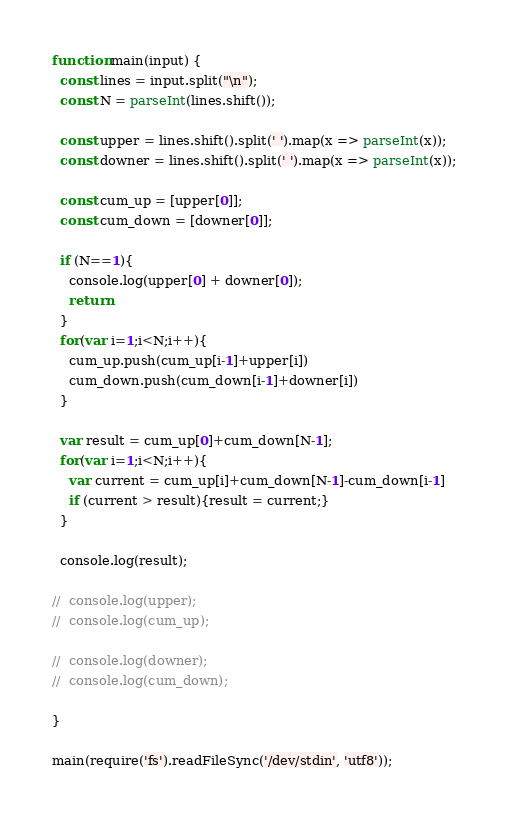Convert code to text. <code><loc_0><loc_0><loc_500><loc_500><_JavaScript_>function main(input) {
  const lines = input.split("\n");
  const N = parseInt(lines.shift());

  const upper = lines.shift().split(' ').map(x => parseInt(x));
  const downer = lines.shift().split(' ').map(x => parseInt(x));

  const cum_up = [upper[0]];
  const cum_down = [downer[0]];

  if (N==1){
    console.log(upper[0] + downer[0]);
    return
  }
  for(var i=1;i<N;i++){
    cum_up.push(cum_up[i-1]+upper[i])
    cum_down.push(cum_down[i-1]+downer[i])
  }

  var result = cum_up[0]+cum_down[N-1];
  for(var i=1;i<N;i++){
    var current = cum_up[i]+cum_down[N-1]-cum_down[i-1]
    if (current > result){result = current;}
  }

  console.log(result);

//  console.log(upper);
//  console.log(cum_up);

//  console.log(downer);
//  console.log(cum_down);

}

main(require('fs').readFileSync('/dev/stdin', 'utf8'));

</code> 